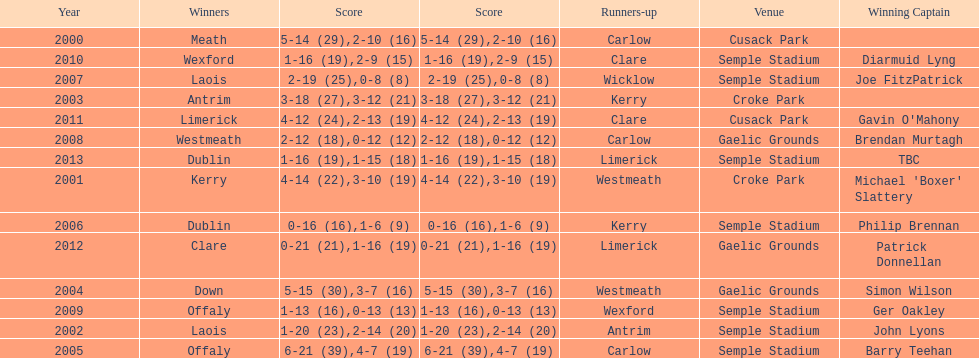Who was the winning captain the last time the competition was held at the gaelic grounds venue? Patrick Donnellan. 